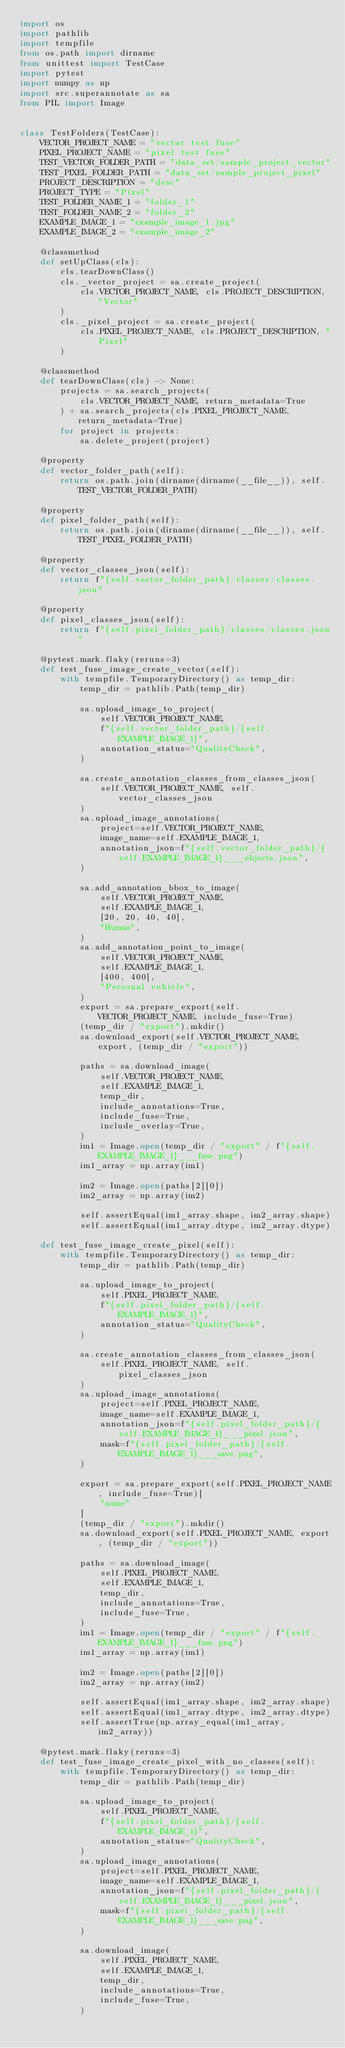Convert code to text. <code><loc_0><loc_0><loc_500><loc_500><_Python_>import os
import pathlib
import tempfile
from os.path import dirname
from unittest import TestCase
import pytest
import numpy as np
import src.superannotate as sa
from PIL import Image


class TestFolders(TestCase):
    VECTOR_PROJECT_NAME = "vector test fuse"
    PIXEL_PROJECT_NAME = "pixel test fuse"
    TEST_VECTOR_FOLDER_PATH = "data_set/sample_project_vector"
    TEST_PIXEL_FOLDER_PATH = "data_set/sample_project_pixel"
    PROJECT_DESCRIPTION = "desc"
    PROJECT_TYPE = "Pixel"
    TEST_FOLDER_NAME_1 = "folder_1"
    TEST_FOLDER_NAME_2 = "folder_2"
    EXAMPLE_IMAGE_1 = "example_image_1.jpg"
    EXAMPLE_IMAGE_2 = "example_image_2"

    @classmethod
    def setUpClass(cls):
        cls.tearDownClass()
        cls._vector_project = sa.create_project(
            cls.VECTOR_PROJECT_NAME, cls.PROJECT_DESCRIPTION, "Vector"
        )
        cls._pixel_project = sa.create_project(
            cls.PIXEL_PROJECT_NAME, cls.PROJECT_DESCRIPTION, "Pixel"
        )

    @classmethod
    def tearDownClass(cls) -> None:
        projects = sa.search_projects(
            cls.VECTOR_PROJECT_NAME, return_metadata=True
        ) + sa.search_projects(cls.PIXEL_PROJECT_NAME, return_metadata=True)
        for project in projects:
            sa.delete_project(project)

    @property
    def vector_folder_path(self):
        return os.path.join(dirname(dirname(__file__)), self.TEST_VECTOR_FOLDER_PATH)

    @property
    def pixel_folder_path(self):
        return os.path.join(dirname(dirname(__file__)), self.TEST_PIXEL_FOLDER_PATH)

    @property
    def vector_classes_json(self):
        return f"{self.vector_folder_path}/classes/classes.json"

    @property
    def pixel_classes_json(self):
        return f"{self.pixel_folder_path}/classes/classes.json"

    @pytest.mark.flaky(reruns=3)
    def test_fuse_image_create_vector(self):
        with tempfile.TemporaryDirectory() as temp_dir:
            temp_dir = pathlib.Path(temp_dir)

            sa.upload_image_to_project(
                self.VECTOR_PROJECT_NAME,
                f"{self.vector_folder_path}/{self.EXAMPLE_IMAGE_1}",
                annotation_status="QualityCheck",
            )

            sa.create_annotation_classes_from_classes_json(
                self.VECTOR_PROJECT_NAME, self.vector_classes_json
            )
            sa.upload_image_annotations(
                project=self.VECTOR_PROJECT_NAME,
                image_name=self.EXAMPLE_IMAGE_1,
                annotation_json=f"{self.vector_folder_path}/{self.EXAMPLE_IMAGE_1}___objects.json",
            )

            sa.add_annotation_bbox_to_image(
                self.VECTOR_PROJECT_NAME,
                self.EXAMPLE_IMAGE_1,
                [20, 20, 40, 40],
                "Human",
            )
            sa.add_annotation_point_to_image(
                self.VECTOR_PROJECT_NAME,
                self.EXAMPLE_IMAGE_1,
                [400, 400],
                "Personal vehicle",
            )
            export = sa.prepare_export(self.VECTOR_PROJECT_NAME, include_fuse=True)
            (temp_dir / "export").mkdir()
            sa.download_export(self.VECTOR_PROJECT_NAME, export, (temp_dir / "export"))

            paths = sa.download_image(
                self.VECTOR_PROJECT_NAME,
                self.EXAMPLE_IMAGE_1,
                temp_dir,
                include_annotations=True,
                include_fuse=True,
                include_overlay=True,
            )
            im1 = Image.open(temp_dir / "export" / f"{self.EXAMPLE_IMAGE_1}___fuse.png")
            im1_array = np.array(im1)

            im2 = Image.open(paths[2][0])
            im2_array = np.array(im2)

            self.assertEqual(im1_array.shape, im2_array.shape)
            self.assertEqual(im1_array.dtype, im2_array.dtype)

    def test_fuse_image_create_pixel(self):
        with tempfile.TemporaryDirectory() as temp_dir:
            temp_dir = pathlib.Path(temp_dir)

            sa.upload_image_to_project(
                self.PIXEL_PROJECT_NAME,
                f"{self.pixel_folder_path}/{self.EXAMPLE_IMAGE_1}",
                annotation_status="QualityCheck",
            )

            sa.create_annotation_classes_from_classes_json(
                self.PIXEL_PROJECT_NAME, self.pixel_classes_json
            )
            sa.upload_image_annotations(
                project=self.PIXEL_PROJECT_NAME,
                image_name=self.EXAMPLE_IMAGE_1,
                annotation_json=f"{self.pixel_folder_path}/{self.EXAMPLE_IMAGE_1}___pixel.json",
                mask=f"{self.pixel_folder_path}/{self.EXAMPLE_IMAGE_1}___save.png",
            )

            export = sa.prepare_export(self.PIXEL_PROJECT_NAME, include_fuse=True)[
                "name"
            ]
            (temp_dir / "export").mkdir()
            sa.download_export(self.PIXEL_PROJECT_NAME, export, (temp_dir / "export"))

            paths = sa.download_image(
                self.PIXEL_PROJECT_NAME,
                self.EXAMPLE_IMAGE_1,
                temp_dir,
                include_annotations=True,
                include_fuse=True,
            )
            im1 = Image.open(temp_dir / "export" / f"{self.EXAMPLE_IMAGE_1}___fuse.png")
            im1_array = np.array(im1)

            im2 = Image.open(paths[2][0])
            im2_array = np.array(im2)

            self.assertEqual(im1_array.shape, im2_array.shape)
            self.assertEqual(im1_array.dtype, im2_array.dtype)
            self.assertTrue(np.array_equal(im1_array, im2_array))

    @pytest.mark.flaky(reruns=3)
    def test_fuse_image_create_pixel_with_no_classes(self):
        with tempfile.TemporaryDirectory() as temp_dir:
            temp_dir = pathlib.Path(temp_dir)

            sa.upload_image_to_project(
                self.PIXEL_PROJECT_NAME,
                f"{self.pixel_folder_path}/{self.EXAMPLE_IMAGE_1}",
                annotation_status="QualityCheck",
            )
            sa.upload_image_annotations(
                project=self.PIXEL_PROJECT_NAME,
                image_name=self.EXAMPLE_IMAGE_1,
                annotation_json=f"{self.pixel_folder_path}/{self.EXAMPLE_IMAGE_1}___pixel.json",
                mask=f"{self.pixel_folder_path}/{self.EXAMPLE_IMAGE_1}___save.png",
            )

            sa.download_image(
                self.PIXEL_PROJECT_NAME,
                self.EXAMPLE_IMAGE_1,
                temp_dir,
                include_annotations=True,
                include_fuse=True,
            )</code> 